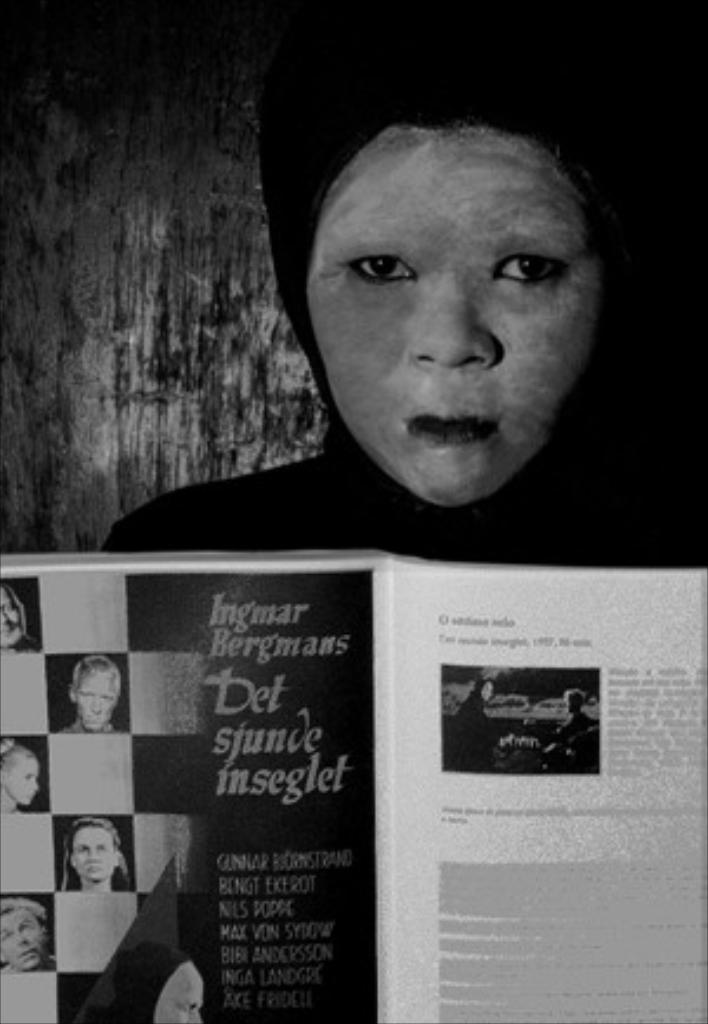What is present in the image? There is a person in the image. What is the person wearing? The person is wearing a black dress. What is the person holding in her hands? The person is holding a book in her hands. What type of engine can be seen in the image? There is no engine present in the image; it features a person wearing a black dress and holding a book. 